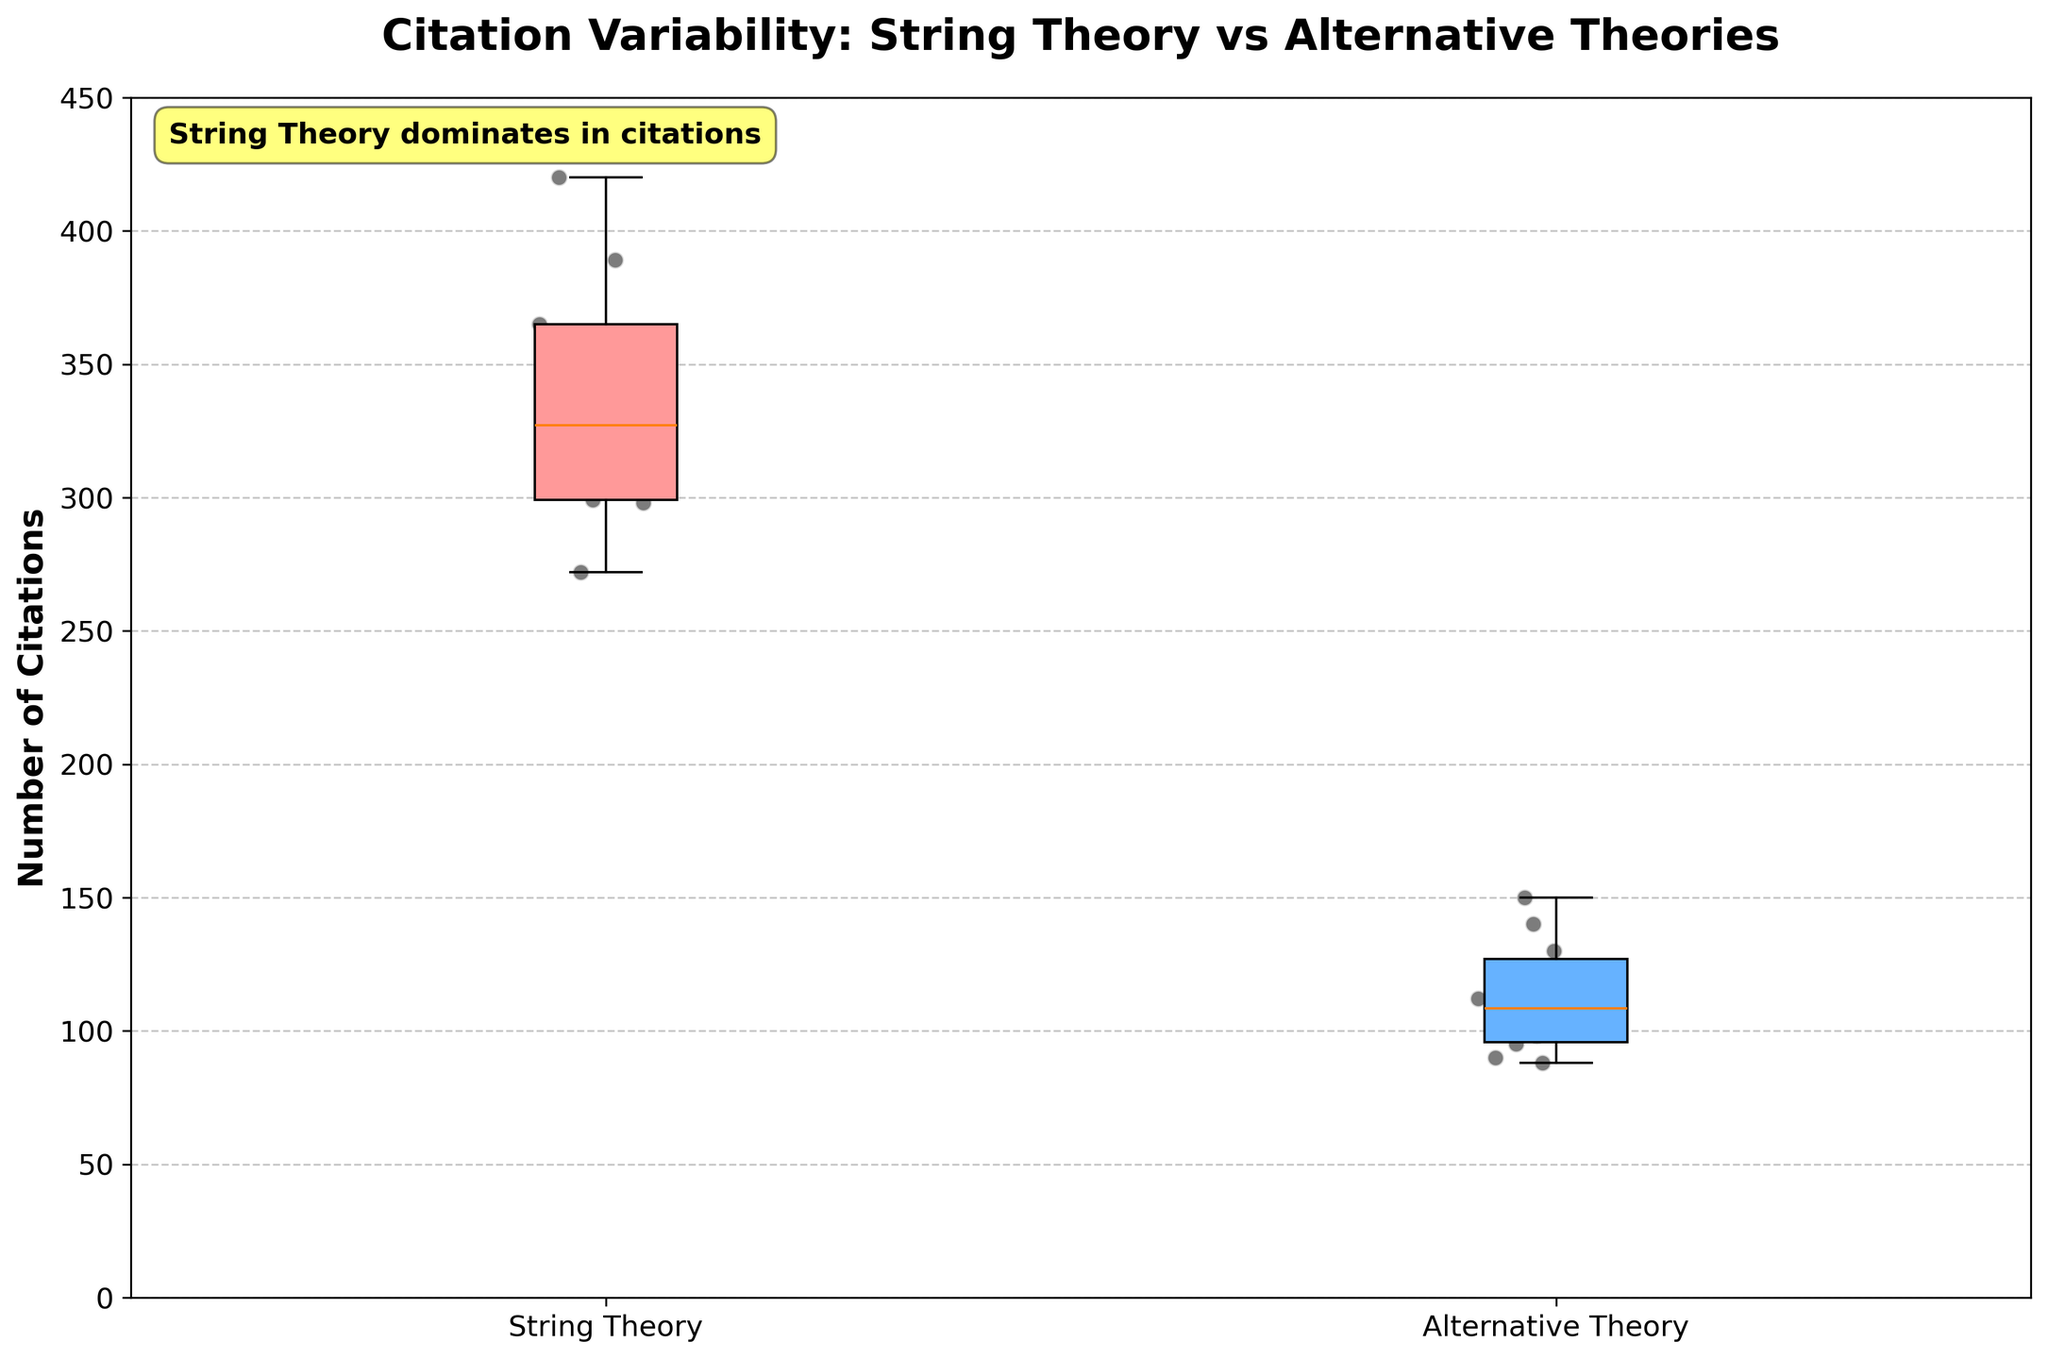What is the title of the plot? The title is displayed at the top of the plot in bold and larger font size, helping to provide context for the data being analyzed.
Answer: Citation Variability: String Theory vs Alternative Theories What does the y-axis represent? The y-axis label indicates what the data being plotted measures.
Answer: Number of Citations How many data points are there for String Theory? Count the number of scatter points within the String Theory box plot.
Answer: 9 Which theory type has the higher maximum citation? Look at the upper whisker and the highest scatter points in each box plot to determine the maximum citation counts.
Answer: String Theory What range of citations do most String Theory papers fall into? Looking at the box plot for String Theory, observe the interquartile range (IQR), which spans from the lower quartile to the upper quartile of the data.
Answer: 298 to 389 What is the interquartile range (IQR) for Alternative Theory papers? The IQR is calculated as the difference between the third quartile (Q3) and the first quartile (Q1) in the box plot for Alternative Theory.
Answer: 150 - 90 = 60 Which theory has more variability in citation counts? Variability can be assessed by comparing the lengths of the boxes and the spread of the scatter points outside the boxes.
Answer: String Theory Are there any outliers in the Alternative Theory data? Outliers are typically represented by individual scatter points that fall beyond the whiskers of the box plot.
Answer: No How does the median citation count for String Theory compare to the median citation count for Alternative Theory? The median is the line inside the box plot, so comparing the positions of the lines in each box plot provides this information.
Answer: Higher for String Theory What does the annotation in the plot indicate? The annotation provides additional insight or highlights a particular aspect of the data, displayed as a text box within the plot.
Answer: String Theory dominates in citations 